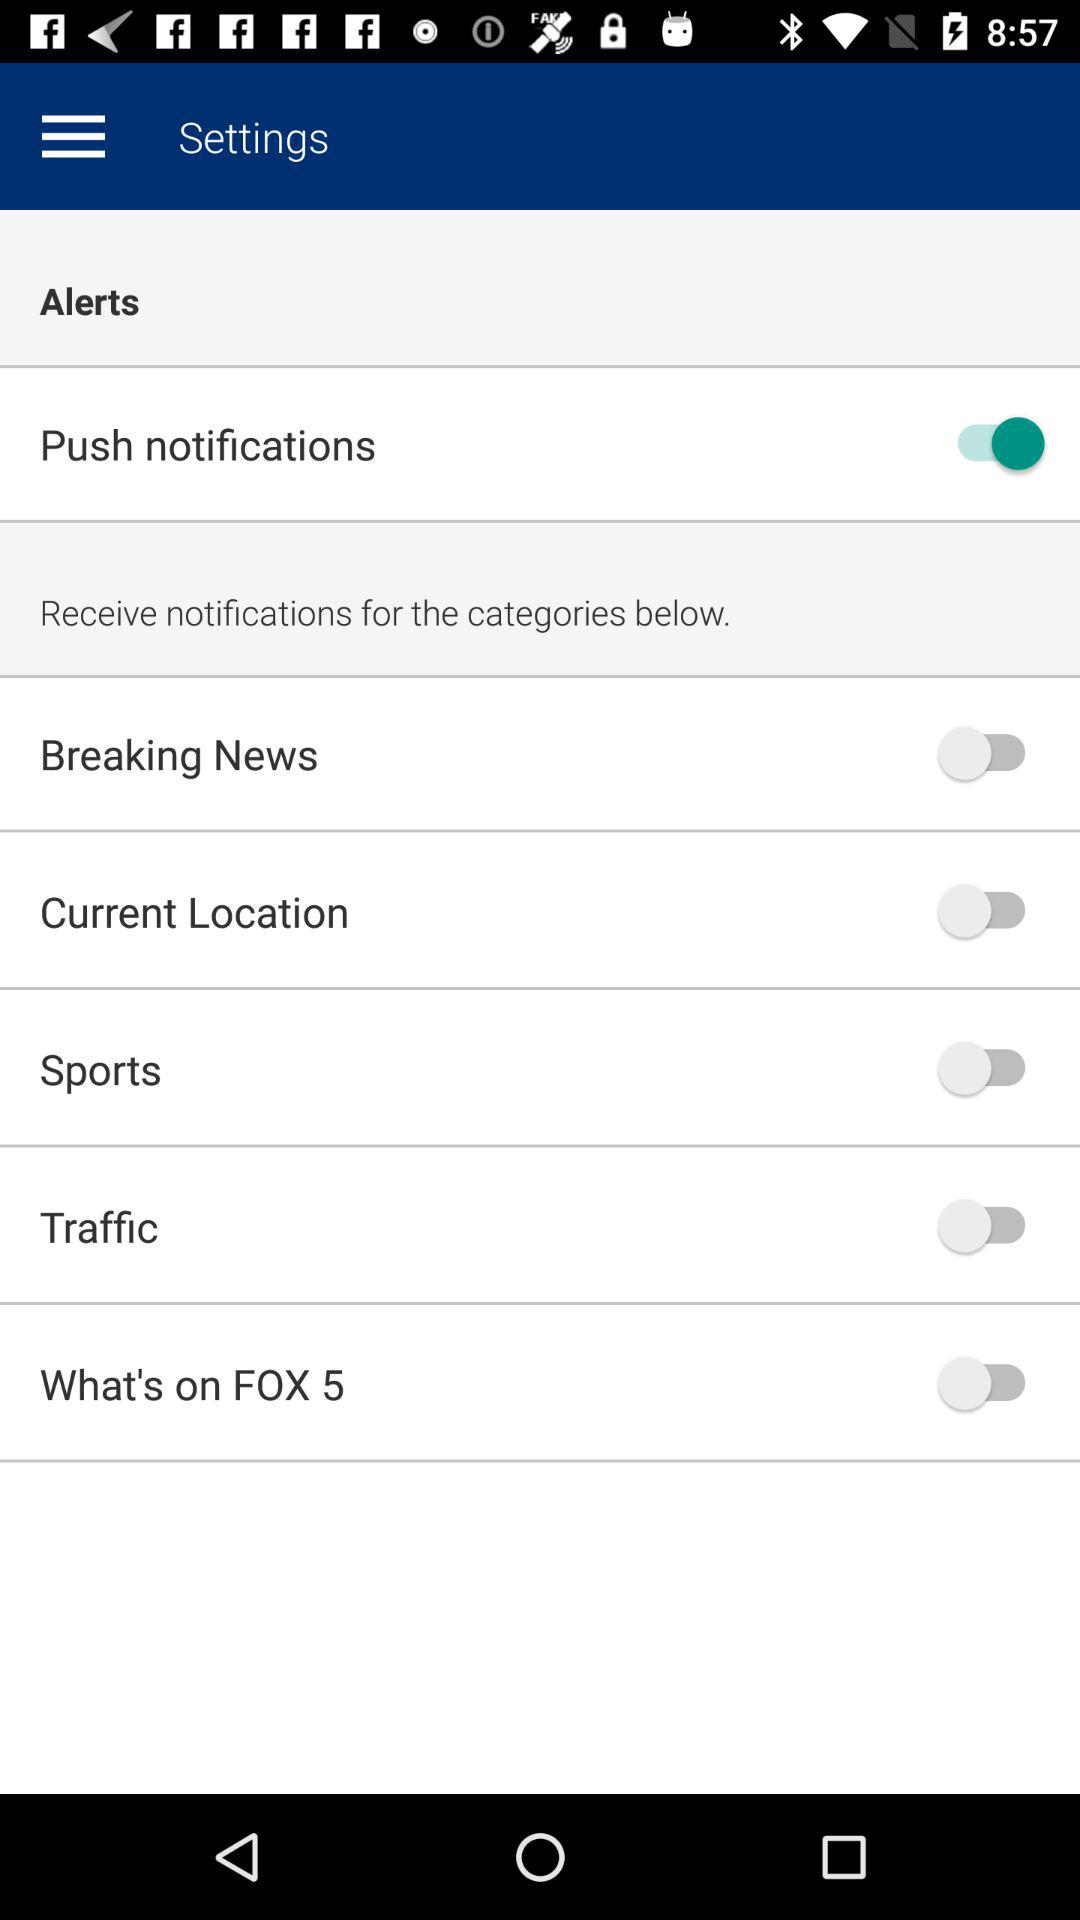What is the status of the "Push notifications" alert? The status is "on". 